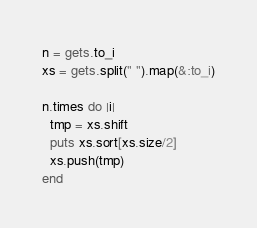Convert code to text. <code><loc_0><loc_0><loc_500><loc_500><_Ruby_>n = gets.to_i
xs = gets.split(" ").map(&:to_i)

n.times do |i|
  tmp = xs.shift
  puts xs.sort[xs.size/2]
  xs.push(tmp)
end</code> 